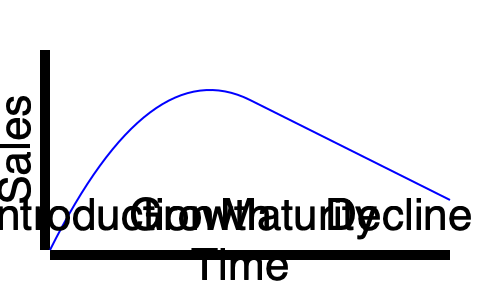As an experienced business professional, you're reviewing a high school student's business plan for a new eco-friendly water bottle. The student has presented you with this product life cycle diagram. At which stage would you recommend implementing a product extension strategy to maximize the product's lifespan and profitability? To answer this question, we need to analyze each stage of the product life cycle and understand when a product extension strategy would be most effective:

1. Introduction Stage: This is when the product is first launched. Sales are low, and marketing costs are high. It's too early for a product extension strategy.

2. Growth Stage: Sales are increasing rapidly. The focus is on gaining market share and establishing the brand. It's still premature for product extension.

3. Maturity Stage: This is where sales reach their peak and start to level off. The market is saturated, and competition is intense. Key characteristics of this stage include:
   - Slowing sales growth
   - Increasing competition
   - Pressure on profit margins
   - Need for differentiation

4. Decline Stage: Sales and profits are declining. It's usually too late to implement effective product extension strategies at this point.

The maturity stage is the ideal time to implement a product extension strategy because:
- The product has established a strong market presence
- There's a need to differentiate from competitors
- It can help maintain or increase market share
- It can potentially rejuvenate sales and prolong the product's life cycle

Product extension strategies in the maturity stage might include:
- Introducing new features or designs
- Targeting new market segments
- Developing new uses for the product

By implementing these strategies during the maturity stage, the business can potentially delay the onset of the decline stage and maximize the product's lifespan and profitability.
Answer: Maturity stage 